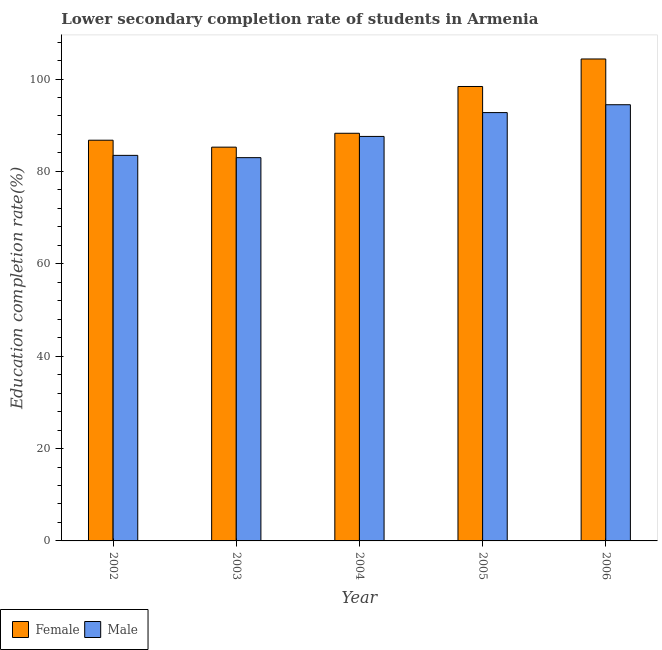How many different coloured bars are there?
Your answer should be compact. 2. What is the education completion rate of female students in 2002?
Offer a terse response. 86.76. Across all years, what is the maximum education completion rate of male students?
Give a very brief answer. 94.44. Across all years, what is the minimum education completion rate of female students?
Give a very brief answer. 85.26. In which year was the education completion rate of male students minimum?
Ensure brevity in your answer.  2003. What is the total education completion rate of female students in the graph?
Give a very brief answer. 463. What is the difference between the education completion rate of male students in 2002 and that in 2004?
Provide a short and direct response. -4.1. What is the difference between the education completion rate of female students in 2004 and the education completion rate of male students in 2002?
Ensure brevity in your answer.  1.5. What is the average education completion rate of male students per year?
Ensure brevity in your answer.  88.24. In how many years, is the education completion rate of male students greater than 84 %?
Provide a succinct answer. 3. What is the ratio of the education completion rate of female students in 2004 to that in 2005?
Give a very brief answer. 0.9. What is the difference between the highest and the second highest education completion rate of female students?
Make the answer very short. 5.96. What is the difference between the highest and the lowest education completion rate of female students?
Your response must be concise. 19.09. Is the sum of the education completion rate of male students in 2003 and 2006 greater than the maximum education completion rate of female students across all years?
Offer a very short reply. Yes. How many bars are there?
Offer a terse response. 10. How many years are there in the graph?
Your answer should be compact. 5. Does the graph contain any zero values?
Offer a terse response. No. What is the title of the graph?
Your response must be concise. Lower secondary completion rate of students in Armenia. Does "Quality of trade" appear as one of the legend labels in the graph?
Make the answer very short. No. What is the label or title of the X-axis?
Your answer should be compact. Year. What is the label or title of the Y-axis?
Ensure brevity in your answer.  Education completion rate(%). What is the Education completion rate(%) of Female in 2002?
Provide a short and direct response. 86.76. What is the Education completion rate(%) in Male in 2002?
Ensure brevity in your answer.  83.47. What is the Education completion rate(%) of Female in 2003?
Ensure brevity in your answer.  85.26. What is the Education completion rate(%) of Male in 2003?
Offer a terse response. 82.98. What is the Education completion rate(%) in Female in 2004?
Keep it short and to the point. 88.26. What is the Education completion rate(%) of Male in 2004?
Ensure brevity in your answer.  87.57. What is the Education completion rate(%) of Female in 2005?
Offer a very short reply. 98.39. What is the Education completion rate(%) in Male in 2005?
Your response must be concise. 92.74. What is the Education completion rate(%) in Female in 2006?
Ensure brevity in your answer.  104.35. What is the Education completion rate(%) of Male in 2006?
Make the answer very short. 94.44. Across all years, what is the maximum Education completion rate(%) in Female?
Provide a succinct answer. 104.35. Across all years, what is the maximum Education completion rate(%) in Male?
Keep it short and to the point. 94.44. Across all years, what is the minimum Education completion rate(%) of Female?
Your answer should be compact. 85.26. Across all years, what is the minimum Education completion rate(%) in Male?
Give a very brief answer. 82.98. What is the total Education completion rate(%) of Female in the graph?
Your response must be concise. 463. What is the total Education completion rate(%) of Male in the graph?
Make the answer very short. 441.21. What is the difference between the Education completion rate(%) of Female in 2002 and that in 2003?
Give a very brief answer. 1.5. What is the difference between the Education completion rate(%) of Male in 2002 and that in 2003?
Your answer should be compact. 0.49. What is the difference between the Education completion rate(%) of Female in 2002 and that in 2004?
Offer a terse response. -1.5. What is the difference between the Education completion rate(%) of Male in 2002 and that in 2004?
Provide a succinct answer. -4.1. What is the difference between the Education completion rate(%) of Female in 2002 and that in 2005?
Make the answer very short. -11.63. What is the difference between the Education completion rate(%) in Male in 2002 and that in 2005?
Keep it short and to the point. -9.26. What is the difference between the Education completion rate(%) in Female in 2002 and that in 2006?
Your response must be concise. -17.59. What is the difference between the Education completion rate(%) of Male in 2002 and that in 2006?
Your response must be concise. -10.96. What is the difference between the Education completion rate(%) in Female in 2003 and that in 2004?
Give a very brief answer. -3. What is the difference between the Education completion rate(%) of Male in 2003 and that in 2004?
Keep it short and to the point. -4.59. What is the difference between the Education completion rate(%) of Female in 2003 and that in 2005?
Provide a succinct answer. -13.13. What is the difference between the Education completion rate(%) of Male in 2003 and that in 2005?
Your response must be concise. -9.76. What is the difference between the Education completion rate(%) of Female in 2003 and that in 2006?
Make the answer very short. -19.09. What is the difference between the Education completion rate(%) of Male in 2003 and that in 2006?
Offer a very short reply. -11.46. What is the difference between the Education completion rate(%) in Female in 2004 and that in 2005?
Provide a short and direct response. -10.13. What is the difference between the Education completion rate(%) of Male in 2004 and that in 2005?
Offer a very short reply. -5.16. What is the difference between the Education completion rate(%) in Female in 2004 and that in 2006?
Ensure brevity in your answer.  -16.09. What is the difference between the Education completion rate(%) in Male in 2004 and that in 2006?
Make the answer very short. -6.86. What is the difference between the Education completion rate(%) in Female in 2005 and that in 2006?
Provide a succinct answer. -5.96. What is the difference between the Education completion rate(%) in Male in 2005 and that in 2006?
Give a very brief answer. -1.7. What is the difference between the Education completion rate(%) in Female in 2002 and the Education completion rate(%) in Male in 2003?
Offer a terse response. 3.78. What is the difference between the Education completion rate(%) in Female in 2002 and the Education completion rate(%) in Male in 2004?
Give a very brief answer. -0.82. What is the difference between the Education completion rate(%) of Female in 2002 and the Education completion rate(%) of Male in 2005?
Your answer should be compact. -5.98. What is the difference between the Education completion rate(%) of Female in 2002 and the Education completion rate(%) of Male in 2006?
Your answer should be compact. -7.68. What is the difference between the Education completion rate(%) in Female in 2003 and the Education completion rate(%) in Male in 2004?
Offer a terse response. -2.32. What is the difference between the Education completion rate(%) of Female in 2003 and the Education completion rate(%) of Male in 2005?
Keep it short and to the point. -7.48. What is the difference between the Education completion rate(%) of Female in 2003 and the Education completion rate(%) of Male in 2006?
Offer a very short reply. -9.18. What is the difference between the Education completion rate(%) of Female in 2004 and the Education completion rate(%) of Male in 2005?
Your answer should be compact. -4.48. What is the difference between the Education completion rate(%) of Female in 2004 and the Education completion rate(%) of Male in 2006?
Your answer should be very brief. -6.18. What is the difference between the Education completion rate(%) in Female in 2005 and the Education completion rate(%) in Male in 2006?
Your answer should be compact. 3.95. What is the average Education completion rate(%) of Female per year?
Ensure brevity in your answer.  92.6. What is the average Education completion rate(%) of Male per year?
Your answer should be compact. 88.24. In the year 2002, what is the difference between the Education completion rate(%) of Female and Education completion rate(%) of Male?
Your answer should be compact. 3.28. In the year 2003, what is the difference between the Education completion rate(%) of Female and Education completion rate(%) of Male?
Your answer should be compact. 2.28. In the year 2004, what is the difference between the Education completion rate(%) of Female and Education completion rate(%) of Male?
Ensure brevity in your answer.  0.68. In the year 2005, what is the difference between the Education completion rate(%) in Female and Education completion rate(%) in Male?
Your answer should be very brief. 5.65. In the year 2006, what is the difference between the Education completion rate(%) of Female and Education completion rate(%) of Male?
Ensure brevity in your answer.  9.91. What is the ratio of the Education completion rate(%) in Female in 2002 to that in 2003?
Provide a short and direct response. 1.02. What is the ratio of the Education completion rate(%) in Male in 2002 to that in 2003?
Keep it short and to the point. 1.01. What is the ratio of the Education completion rate(%) of Male in 2002 to that in 2004?
Offer a terse response. 0.95. What is the ratio of the Education completion rate(%) in Female in 2002 to that in 2005?
Provide a short and direct response. 0.88. What is the ratio of the Education completion rate(%) of Male in 2002 to that in 2005?
Ensure brevity in your answer.  0.9. What is the ratio of the Education completion rate(%) of Female in 2002 to that in 2006?
Your answer should be very brief. 0.83. What is the ratio of the Education completion rate(%) in Male in 2002 to that in 2006?
Your answer should be compact. 0.88. What is the ratio of the Education completion rate(%) of Female in 2003 to that in 2004?
Make the answer very short. 0.97. What is the ratio of the Education completion rate(%) in Male in 2003 to that in 2004?
Provide a succinct answer. 0.95. What is the ratio of the Education completion rate(%) of Female in 2003 to that in 2005?
Provide a short and direct response. 0.87. What is the ratio of the Education completion rate(%) in Male in 2003 to that in 2005?
Provide a short and direct response. 0.89. What is the ratio of the Education completion rate(%) of Female in 2003 to that in 2006?
Keep it short and to the point. 0.82. What is the ratio of the Education completion rate(%) of Male in 2003 to that in 2006?
Your response must be concise. 0.88. What is the ratio of the Education completion rate(%) in Female in 2004 to that in 2005?
Offer a very short reply. 0.9. What is the ratio of the Education completion rate(%) in Male in 2004 to that in 2005?
Provide a succinct answer. 0.94. What is the ratio of the Education completion rate(%) of Female in 2004 to that in 2006?
Provide a short and direct response. 0.85. What is the ratio of the Education completion rate(%) of Male in 2004 to that in 2006?
Give a very brief answer. 0.93. What is the ratio of the Education completion rate(%) in Female in 2005 to that in 2006?
Keep it short and to the point. 0.94. What is the ratio of the Education completion rate(%) of Male in 2005 to that in 2006?
Make the answer very short. 0.98. What is the difference between the highest and the second highest Education completion rate(%) of Female?
Offer a terse response. 5.96. What is the difference between the highest and the second highest Education completion rate(%) of Male?
Your answer should be very brief. 1.7. What is the difference between the highest and the lowest Education completion rate(%) of Female?
Give a very brief answer. 19.09. What is the difference between the highest and the lowest Education completion rate(%) in Male?
Your answer should be very brief. 11.46. 